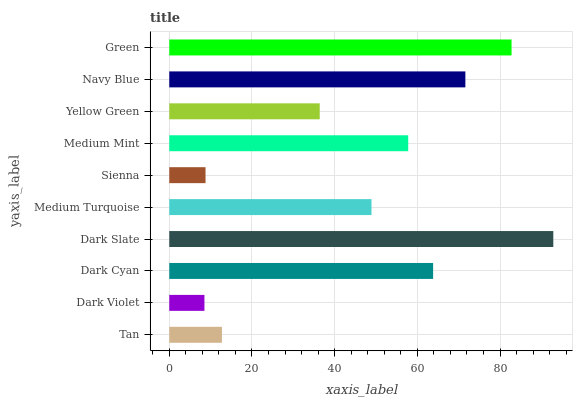Is Dark Violet the minimum?
Answer yes or no. Yes. Is Dark Slate the maximum?
Answer yes or no. Yes. Is Dark Cyan the minimum?
Answer yes or no. No. Is Dark Cyan the maximum?
Answer yes or no. No. Is Dark Cyan greater than Dark Violet?
Answer yes or no. Yes. Is Dark Violet less than Dark Cyan?
Answer yes or no. Yes. Is Dark Violet greater than Dark Cyan?
Answer yes or no. No. Is Dark Cyan less than Dark Violet?
Answer yes or no. No. Is Medium Mint the high median?
Answer yes or no. Yes. Is Medium Turquoise the low median?
Answer yes or no. Yes. Is Medium Turquoise the high median?
Answer yes or no. No. Is Green the low median?
Answer yes or no. No. 